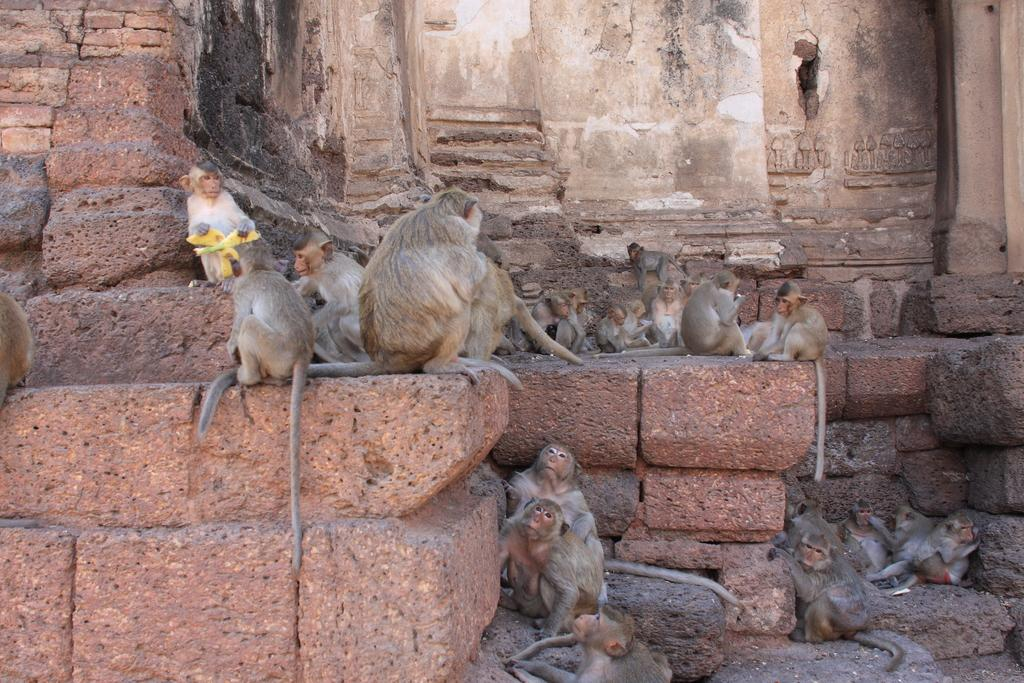What animals are present in the image? There is a group of monkeys in the image. Where are the monkeys located? The monkeys are sitting on a stone wall. What does the mom of the monkeys desire in the image? There is no indication of a mom or any desires in the image; it only shows a group of monkeys sitting on a stone wall. 